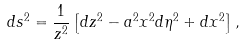Convert formula to latex. <formula><loc_0><loc_0><loc_500><loc_500>d s ^ { 2 } = \frac { 1 } { z ^ { 2 } } \left [ d z ^ { 2 } - a ^ { 2 } x ^ { 2 } d \eta ^ { 2 } + d x ^ { 2 } \right ] ,</formula> 